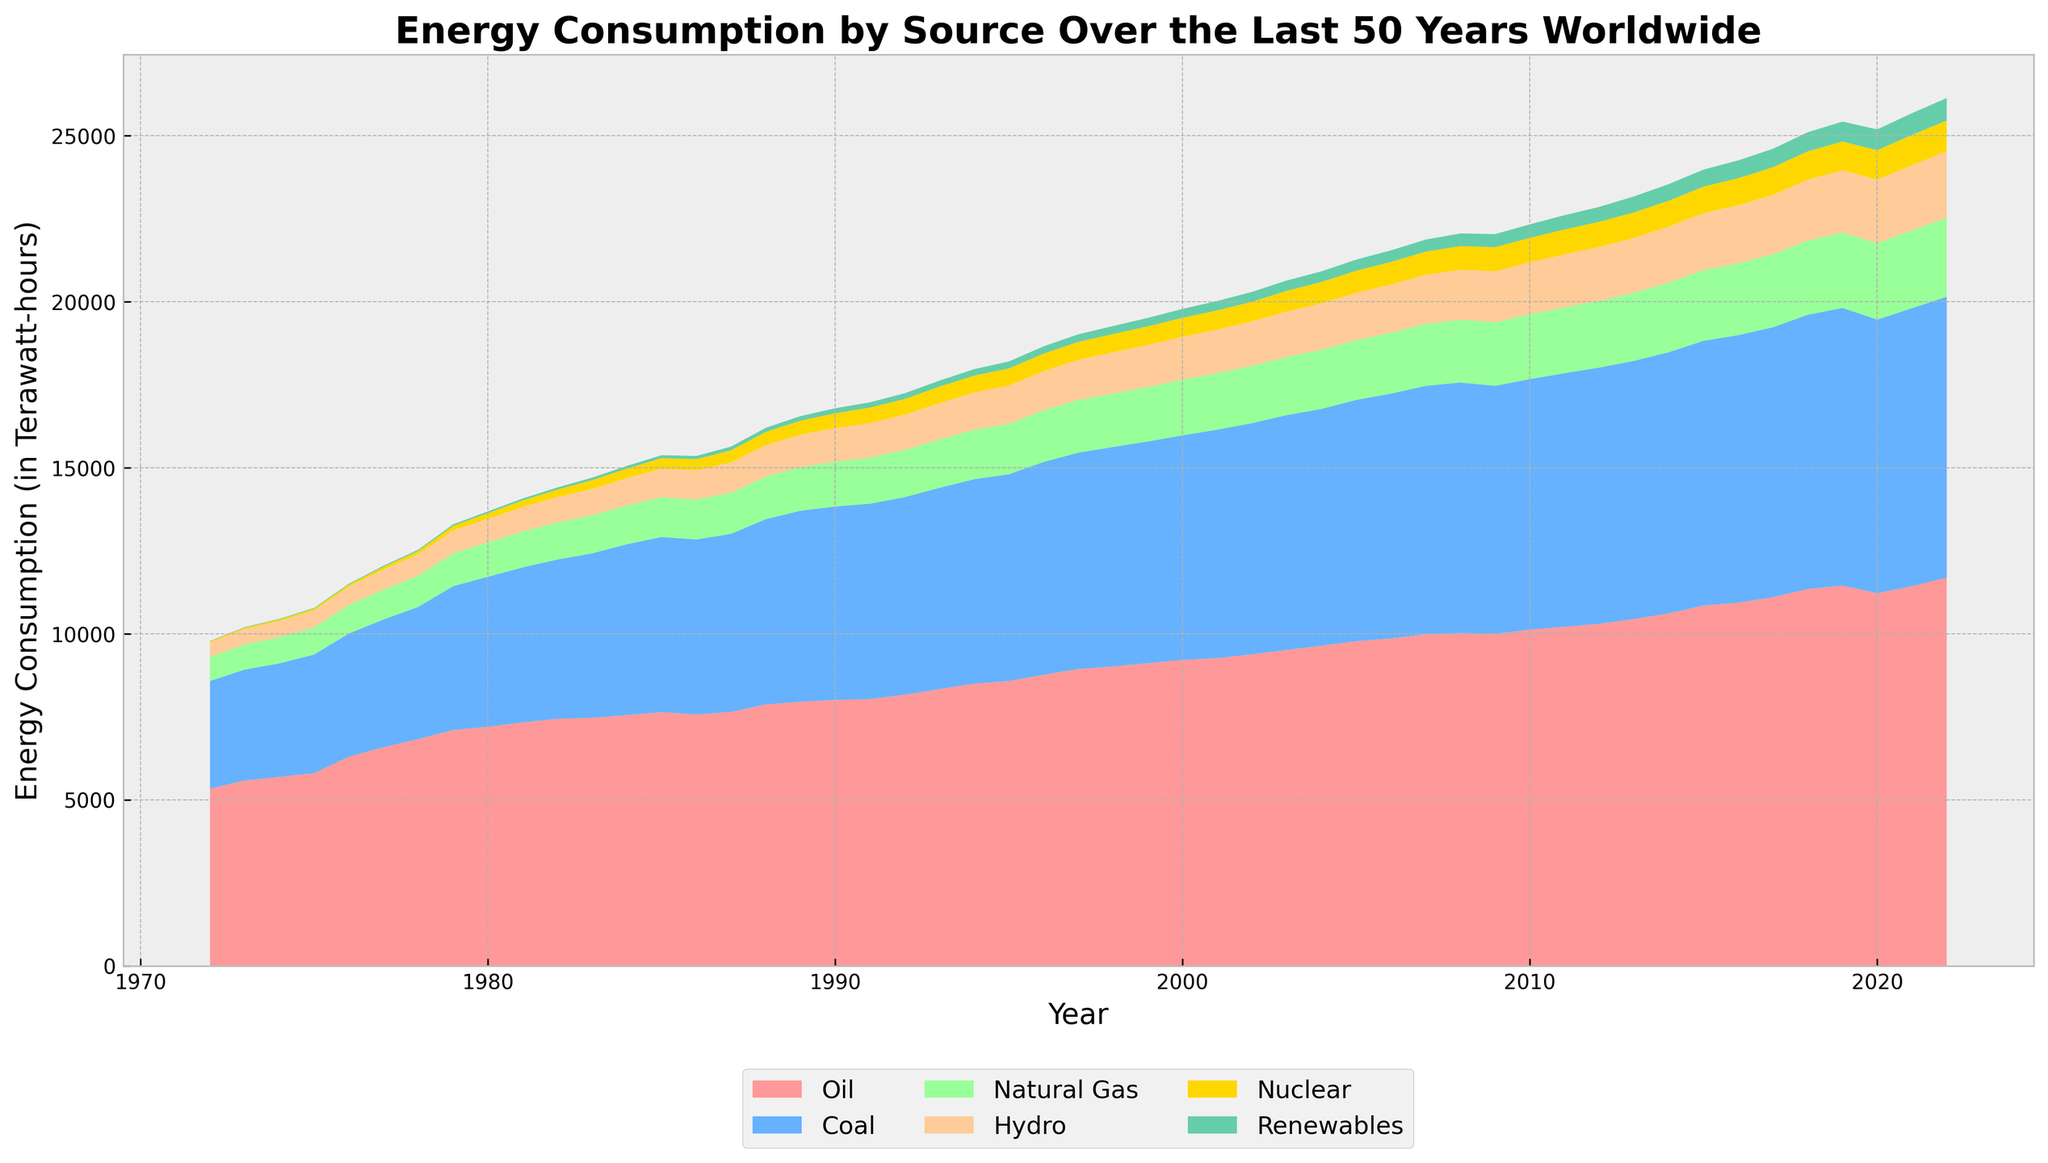Which energy source had the highest consumption in 2022? Look at the endpoint of 2022 on the x-axis and identify the segment with the greatest height. For 2022, the top segment, which is Oil, has the highest height.
Answer: Oil How has the consumption of Renewables changed from 1972 to 2022? Identify the difference in height of the segment representing Renewables at the years 1972 and 2022, moving from a very small height to a significantly larger one.
Answer: Increased significantly In which year did Nuclear energy consumption surpass 500 TWh? Examine the Nuclear band's height. Around the year 1990, the segment for Nuclear energy becomes noticeably larger, indicating it surpassed 500 TWh around that year.
Answer: 1990 What is the relative trend for Coal consumption compared to Natural Gas from 1972 to 2022? Observe the height and changes of the segments for Coal and Natural Gas. Coal generally remains higher than Natural Gas but both show increasing trends.
Answer: Both increased, Coal remains higher Which year showed the highest total energy consumption by all sources combined? Compare the total height (sum of all segments) for each year. Identifying that the overall height is the highest in 2022.
Answer: 2022 What can you infer about the trend of Hydro energy over the last 50 years? Look at the Hydro segment from 1972 to 2022, which shows a gradual increase, but not as steep as some other sources.
Answer: Gradually increased When did Oil consumption start to decline briefly before rising again? Identify the decrease in the Oil segment around 1980 to 1985, where it slightly dips before rising again.
Answer: Around 1980-1985 Which energy source had the least consumption in 2022? At the endpoint for 2022, identify the segment with the smallest height. This smallest segment represents Renewables.
Answer: Renewables 